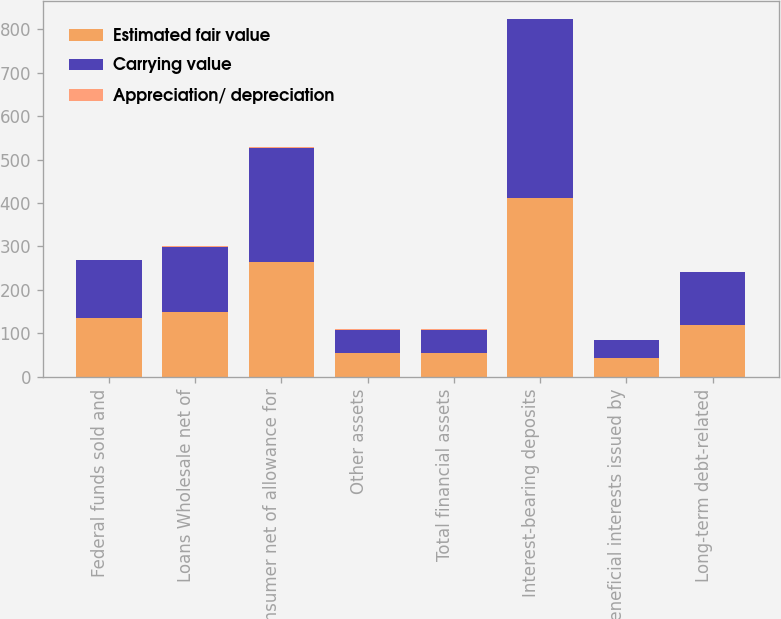Convert chart to OTSL. <chart><loc_0><loc_0><loc_500><loc_500><stacked_bar_chart><ecel><fcel>Federal funds sold and<fcel>Loans Wholesale net of<fcel>Consumer net of allowance for<fcel>Other assets<fcel>Total financial assets<fcel>Interest-bearing deposits<fcel>Beneficial interests issued by<fcel>Long-term debt-related<nl><fcel>Estimated fair value<fcel>134<fcel>147.7<fcel>264.4<fcel>53.4<fcel>54.05<fcel>411.9<fcel>42.2<fcel>119.9<nl><fcel>Carrying value<fcel>134.3<fcel>150.2<fcel>262.7<fcel>54.7<fcel>54.05<fcel>411.7<fcel>42.1<fcel>120.6<nl><fcel>Appreciation/ depreciation<fcel>0.3<fcel>2.5<fcel>1.7<fcel>1.3<fcel>2.4<fcel>0.2<fcel>0.1<fcel>0.7<nl></chart> 